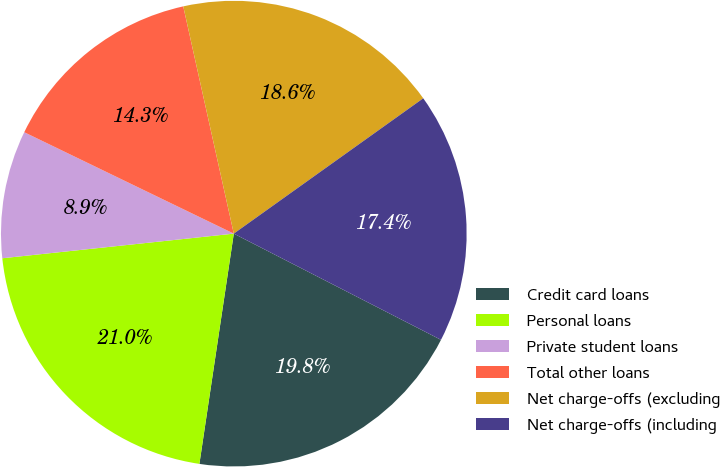Convert chart. <chart><loc_0><loc_0><loc_500><loc_500><pie_chart><fcel>Credit card loans<fcel>Personal loans<fcel>Private student loans<fcel>Total other loans<fcel>Net charge-offs (excluding<fcel>Net charge-offs (including<nl><fcel>19.82%<fcel>20.95%<fcel>8.86%<fcel>14.34%<fcel>18.61%<fcel>17.41%<nl></chart> 